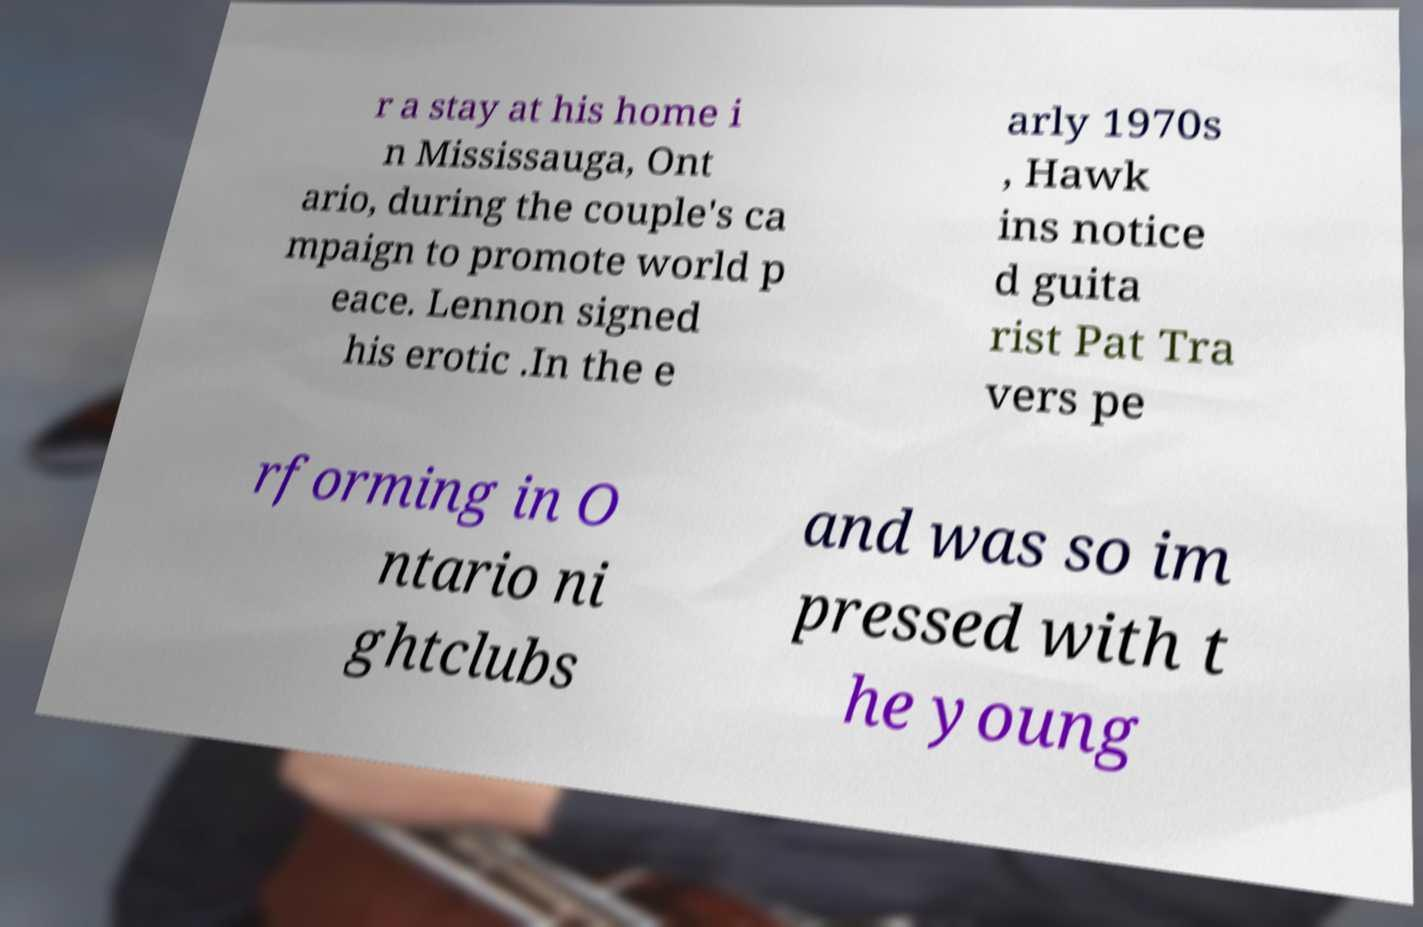Can you read and provide the text displayed in the image?This photo seems to have some interesting text. Can you extract and type it out for me? r a stay at his home i n Mississauga, Ont ario, during the couple's ca mpaign to promote world p eace. Lennon signed his erotic .In the e arly 1970s , Hawk ins notice d guita rist Pat Tra vers pe rforming in O ntario ni ghtclubs and was so im pressed with t he young 